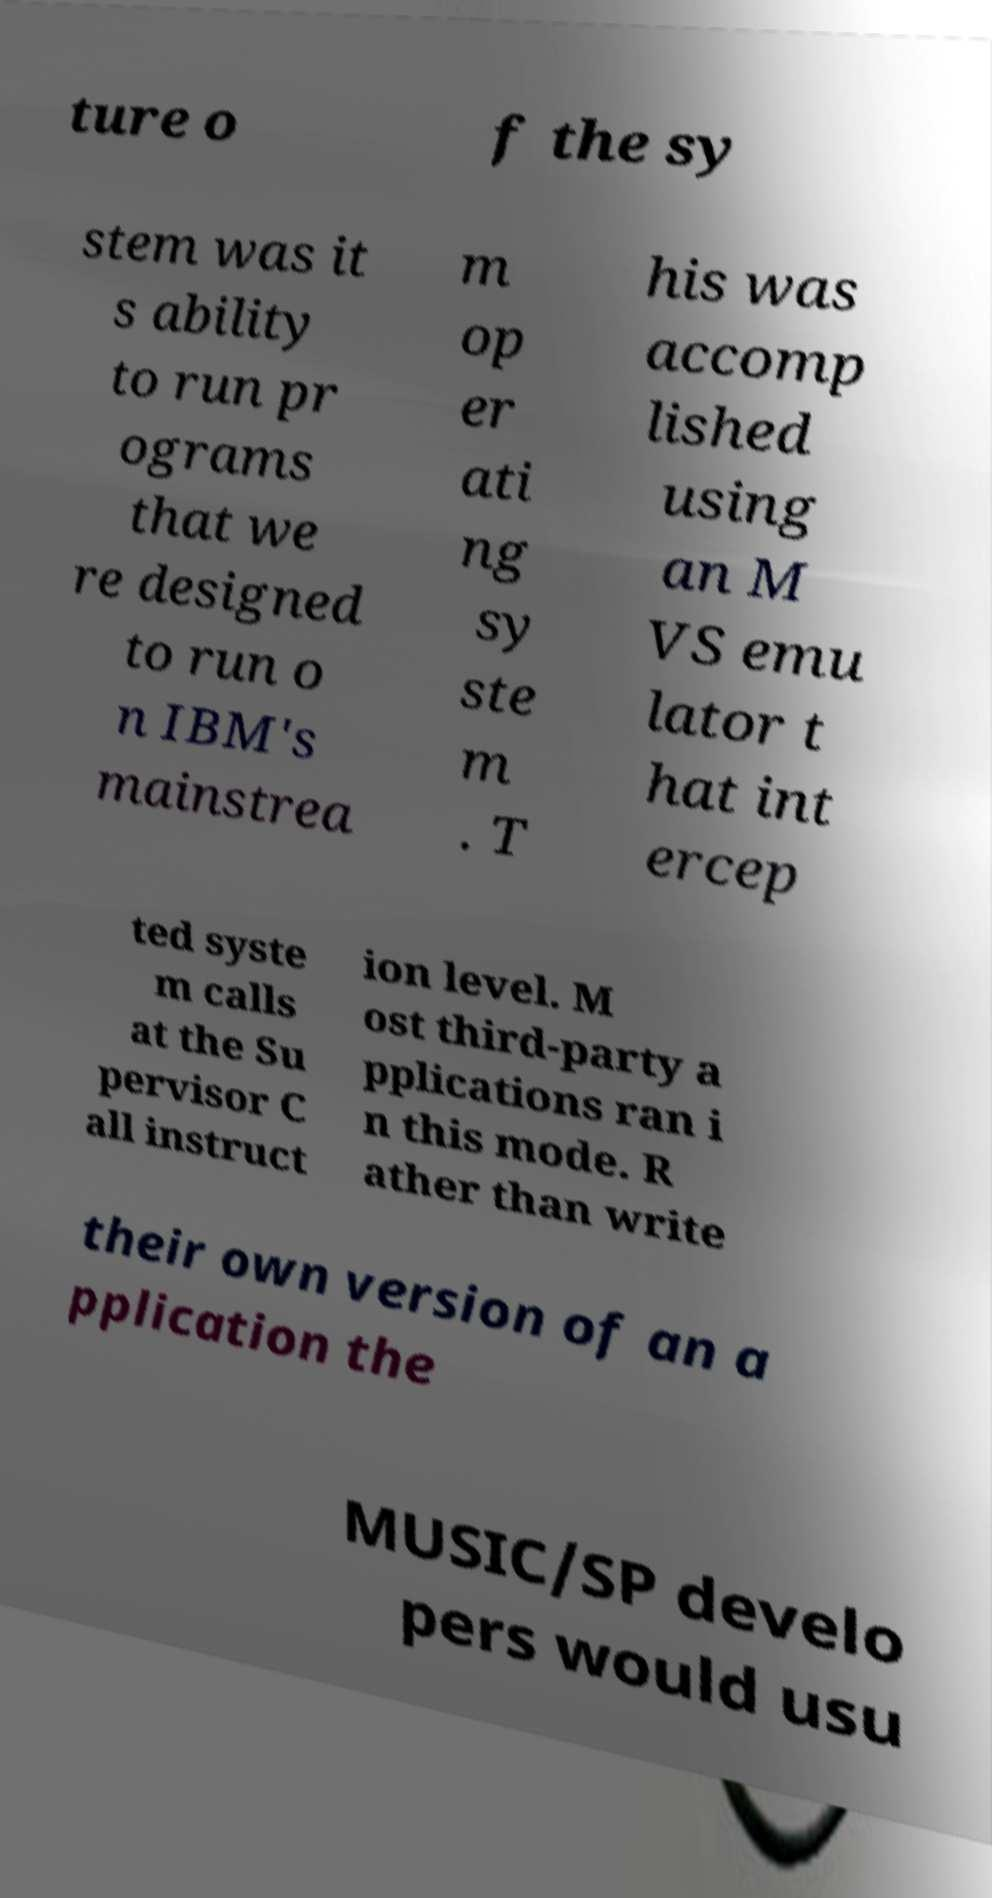Could you extract and type out the text from this image? ture o f the sy stem was it s ability to run pr ograms that we re designed to run o n IBM's mainstrea m op er ati ng sy ste m . T his was accomp lished using an M VS emu lator t hat int ercep ted syste m calls at the Su pervisor C all instruct ion level. M ost third-party a pplications ran i n this mode. R ather than write their own version of an a pplication the MUSIC/SP develo pers would usu 